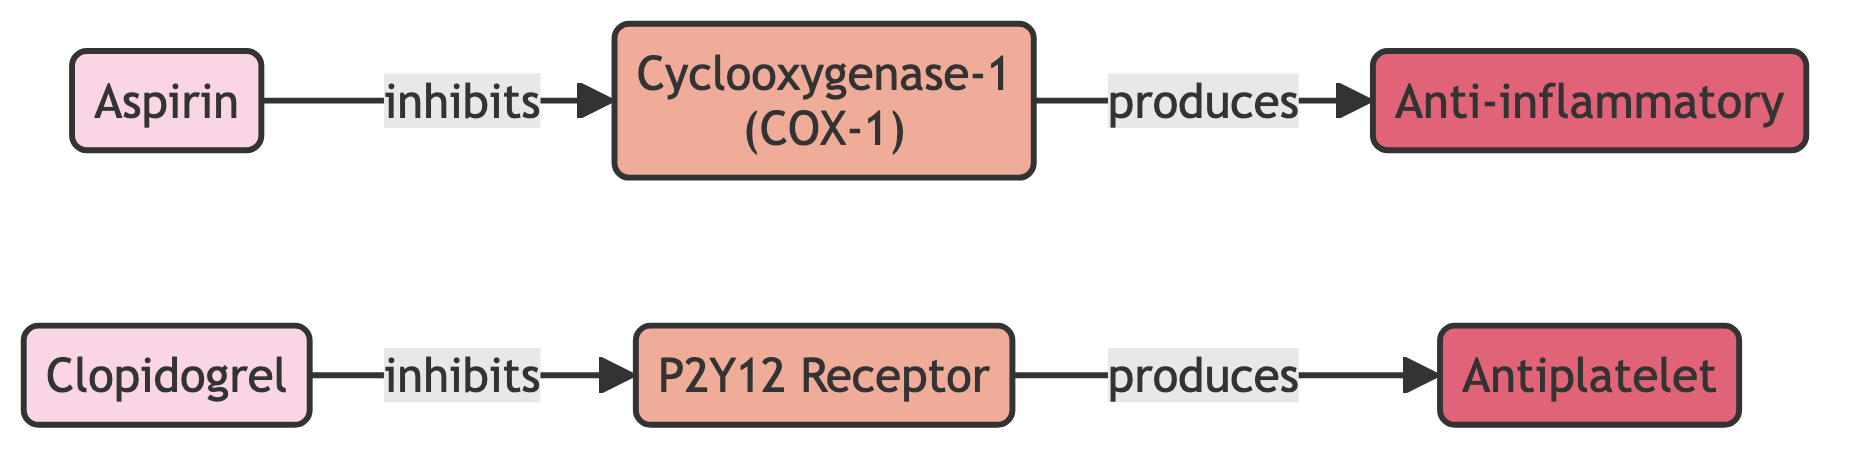What drugs are shown in the diagram? The diagram includes two nodes labeled "Aspirin" and "Clopidogrel," which represent the drugs in the network.
Answer: Aspirin, Clopidogrel Which biological target is inhibited by Aspirin? The edge labeled "inhibits" connects "Aspirin" to "Cyclooxygenase-1 (COX-1)," indicating that Aspirin inhibits this biological target.
Answer: Cyclooxygenase-1 (COX-1) How many edges are present in the diagram? The diagram contains four edges that represent various relationships (inhibits and produces) between the nodes. Counting these edges gives a total of four.
Answer: 4 What effect does Cyclooxygenase-1 produce? The edge labeled "produces" indicates that the connection from "Cyclooxygenase-1 (COX-1)" to "Anti-inflammatory" signifies that COX-1 produces this effect.
Answer: Anti-inflammatory Which effect is produced by the P2Y12 Receptor? The edge labeled "produces" between "P2Y12 Receptor" and "Antiplatelet" shows that this biological target produces the antiplatelet effect.
Answer: Antiplatelet What is the relationship type between Clopidogrel and its target? The edge between "Clopidogrel" and "P2Y12 Receptor" is labeled "inhibits," indicating that Clopidogrel has this type of relationship with its target.
Answer: inhibits Which target is linked to the Anti-inflammatory effect? The relationship indicated by the "produces" edge shows that "Cyclooxygenase-1 (COX-1)" is linked to the Anti-inflammatory effect.
Answer: Cyclooxygenase-1 (COX-1) How many drugs interact with biological targets in the diagram? There are two drugs ("Aspirin" and "Clopidogrel") that interact with their respective biological targets in the diagram. Thus, the count of drugs interacting with biological targets is two.
Answer: 2 Which relationship connects a drug to its effect in the diagram? The relationships found in the diagram include "inhibits" that connect the drugs to their biological targets and "produces" connecting those targets to their effects. The type of relationship that specifically connects a drug to its effect via targets is "produces."
Answer: produces 